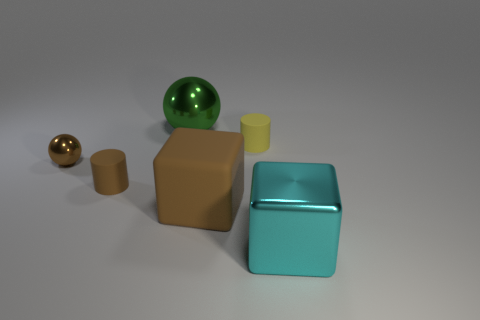Is there any other thing that is the same color as the tiny sphere?
Provide a succinct answer. Yes. There is a big rubber object; does it have the same color as the small matte cylinder that is on the left side of the big brown block?
Your answer should be very brief. Yes. Is the material of the green sphere the same as the small brown object that is right of the tiny brown sphere?
Your answer should be very brief. No. The tiny metal object is what color?
Offer a terse response. Brown. There is a green shiny object; are there any cyan objects to the right of it?
Make the answer very short. Yes. Is the large rubber object the same color as the tiny metallic object?
Offer a very short reply. Yes. What number of other objects have the same color as the big matte object?
Provide a short and direct response. 2. What is the size of the matte cylinder left of the big thing on the left side of the brown cube?
Your response must be concise. Small. What is the shape of the green thing?
Offer a terse response. Sphere. What is the sphere that is to the right of the brown sphere made of?
Provide a succinct answer. Metal. 